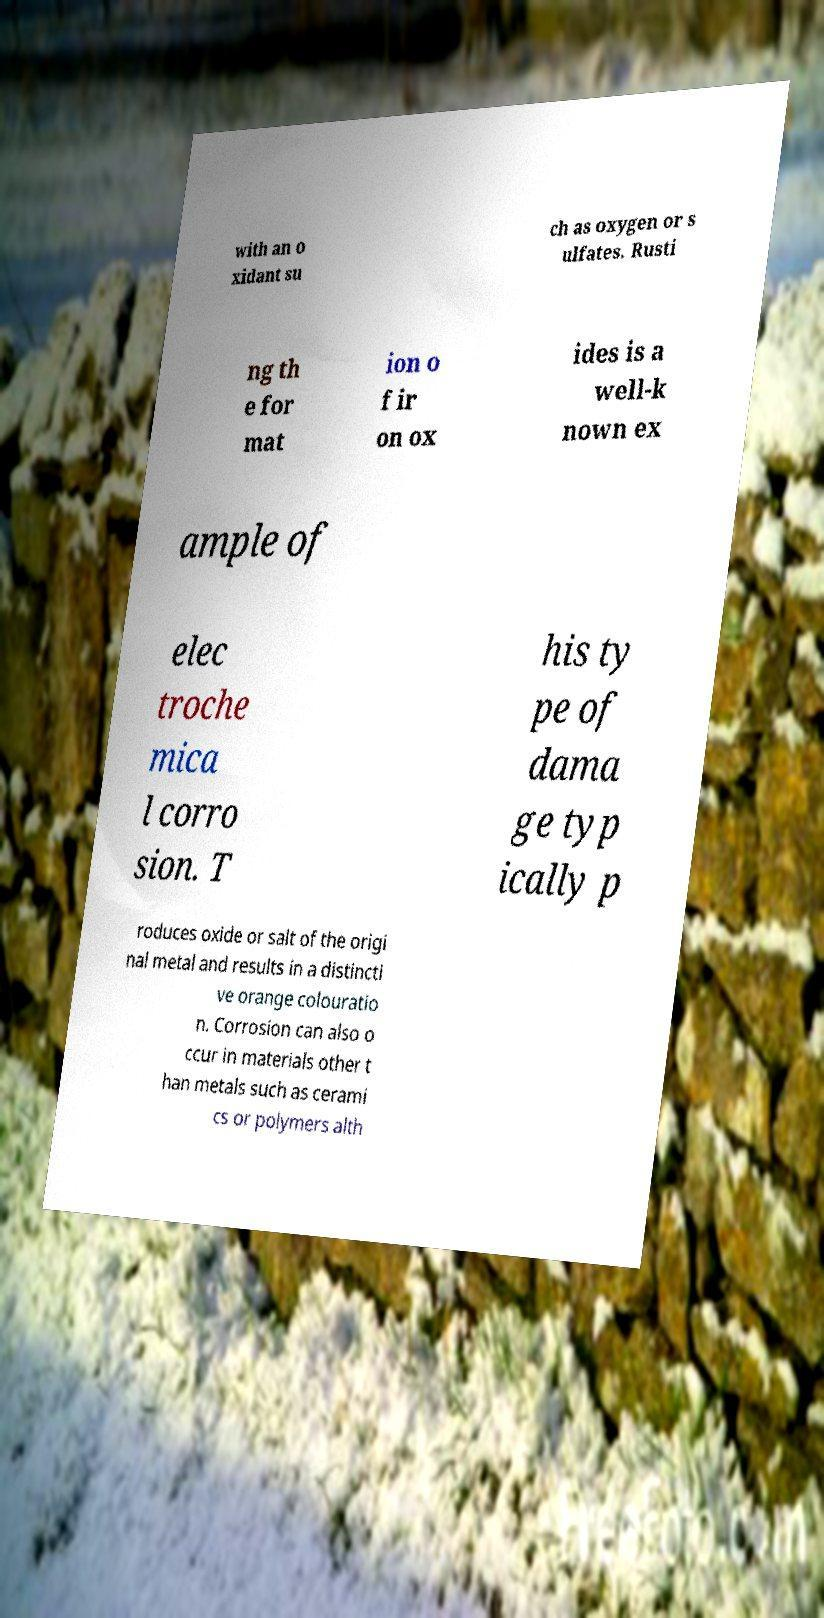Please read and relay the text visible in this image. What does it say? with an o xidant su ch as oxygen or s ulfates. Rusti ng th e for mat ion o f ir on ox ides is a well-k nown ex ample of elec troche mica l corro sion. T his ty pe of dama ge typ ically p roduces oxide or salt of the origi nal metal and results in a distincti ve orange colouratio n. Corrosion can also o ccur in materials other t han metals such as cerami cs or polymers alth 